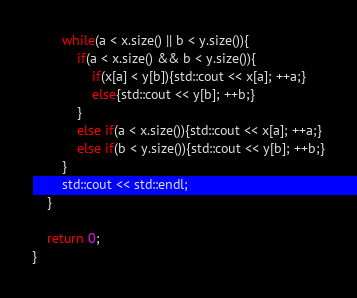Convert code to text. <code><loc_0><loc_0><loc_500><loc_500><_C++_>        while(a < x.size() || b < y.size()){
            if(a < x.size() && b < y.size()){
                if(x[a] < y[b]){std::cout << x[a]; ++a;}
                else{std::cout << y[b]; ++b;}
            }
            else if(a < x.size()){std::cout << x[a]; ++a;}
            else if(b < y.size()){std::cout << y[b]; ++b;}
        }
        std::cout << std::endl;
    }

    return 0;
}
</code> 